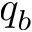Convert formula to latex. <formula><loc_0><loc_0><loc_500><loc_500>q _ { b }</formula> 